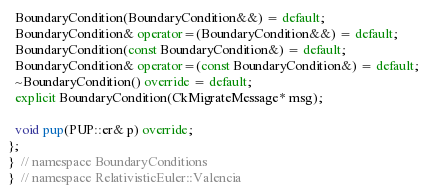<code> <loc_0><loc_0><loc_500><loc_500><_C++_>  BoundaryCondition(BoundaryCondition&&) = default;
  BoundaryCondition& operator=(BoundaryCondition&&) = default;
  BoundaryCondition(const BoundaryCondition&) = default;
  BoundaryCondition& operator=(const BoundaryCondition&) = default;
  ~BoundaryCondition() override = default;
  explicit BoundaryCondition(CkMigrateMessage* msg);

  void pup(PUP::er& p) override;
};
}  // namespace BoundaryConditions
}  // namespace RelativisticEuler::Valencia
</code> 